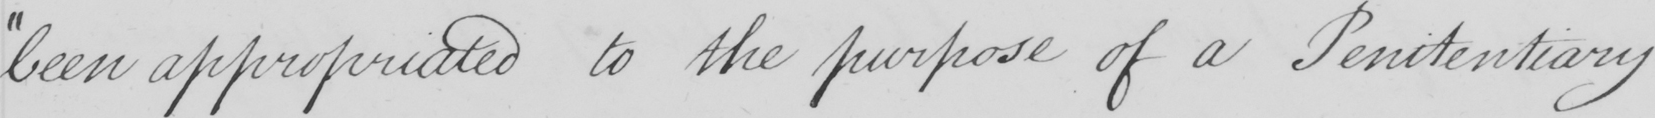Please provide the text content of this handwritten line. been appropriated to the purpose of a Penitentiary 